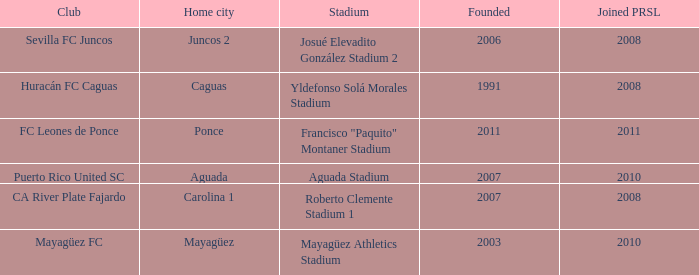When is the latest to join prsl when founded in 2007 and the stadium is roberto clemente stadium 1? 2008.0. 